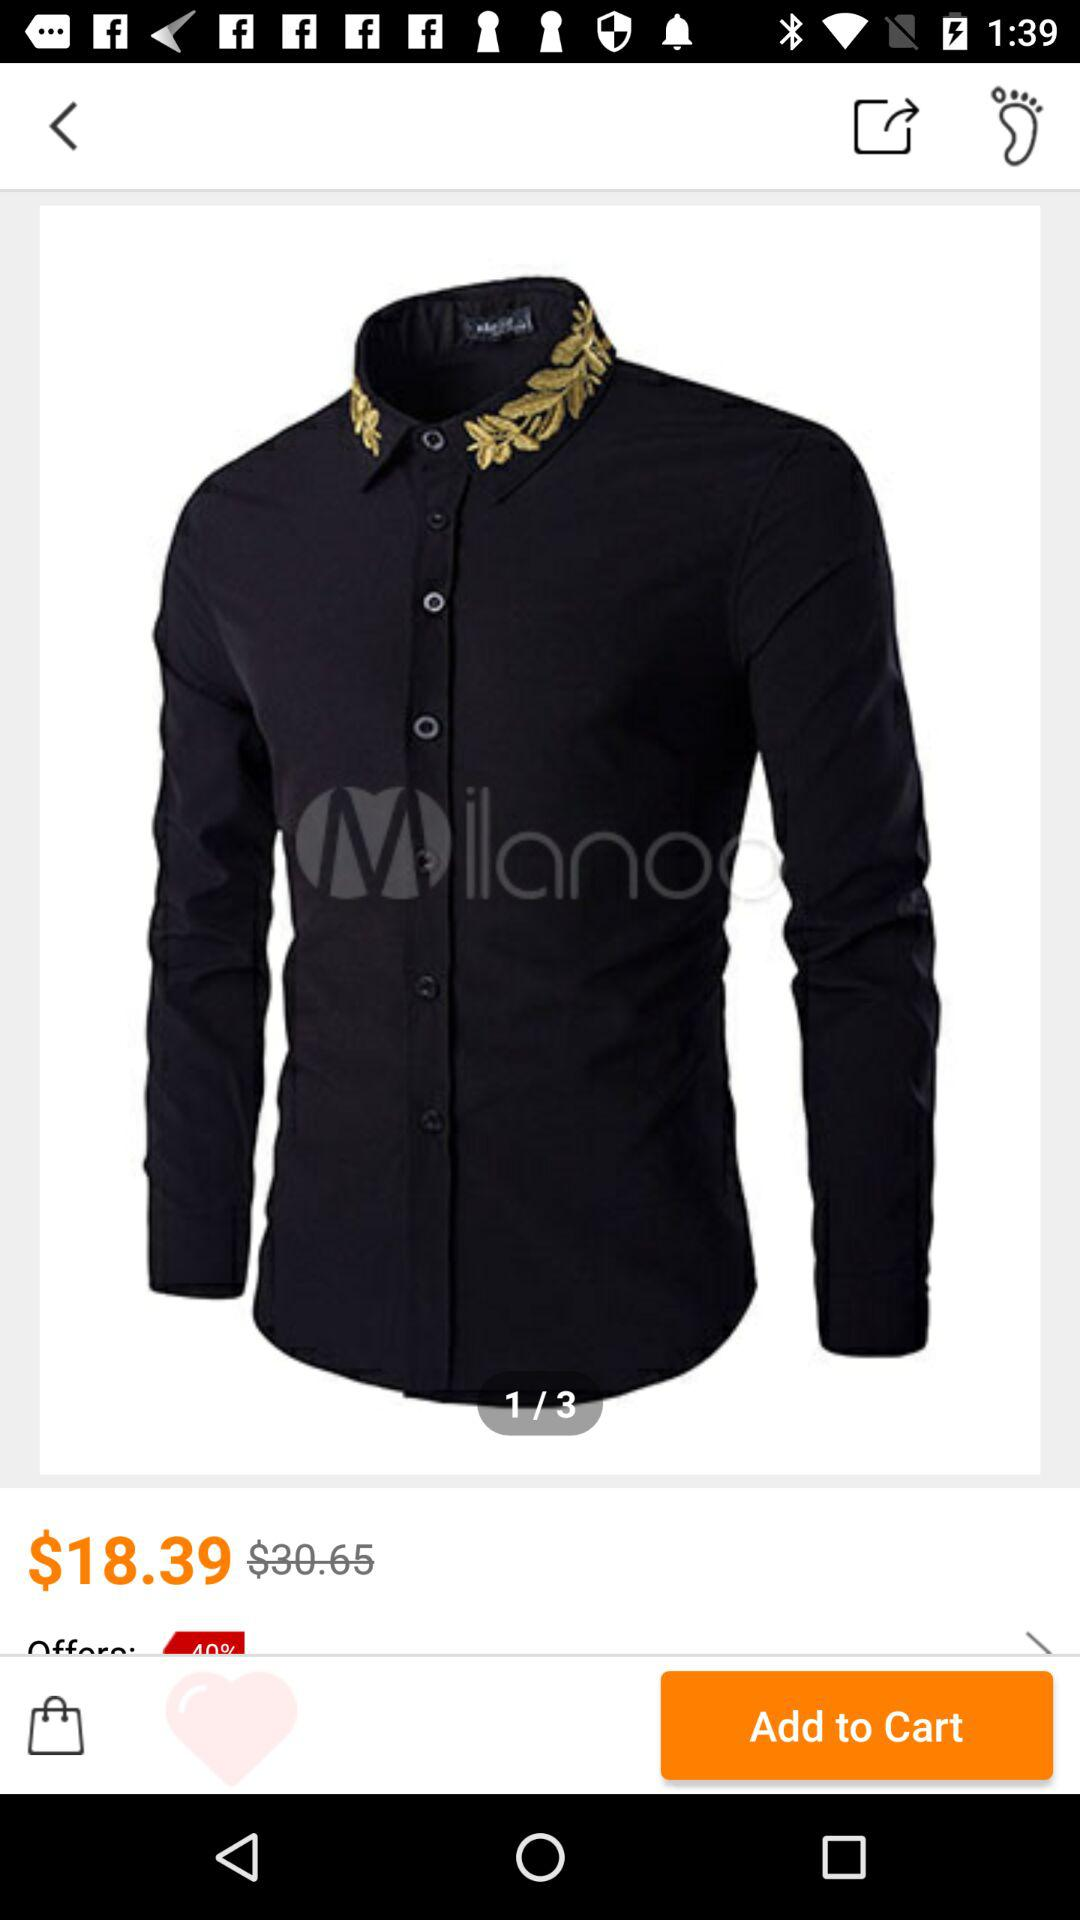What was the original price of a shirt? The original price of the shirt was $30.65. 